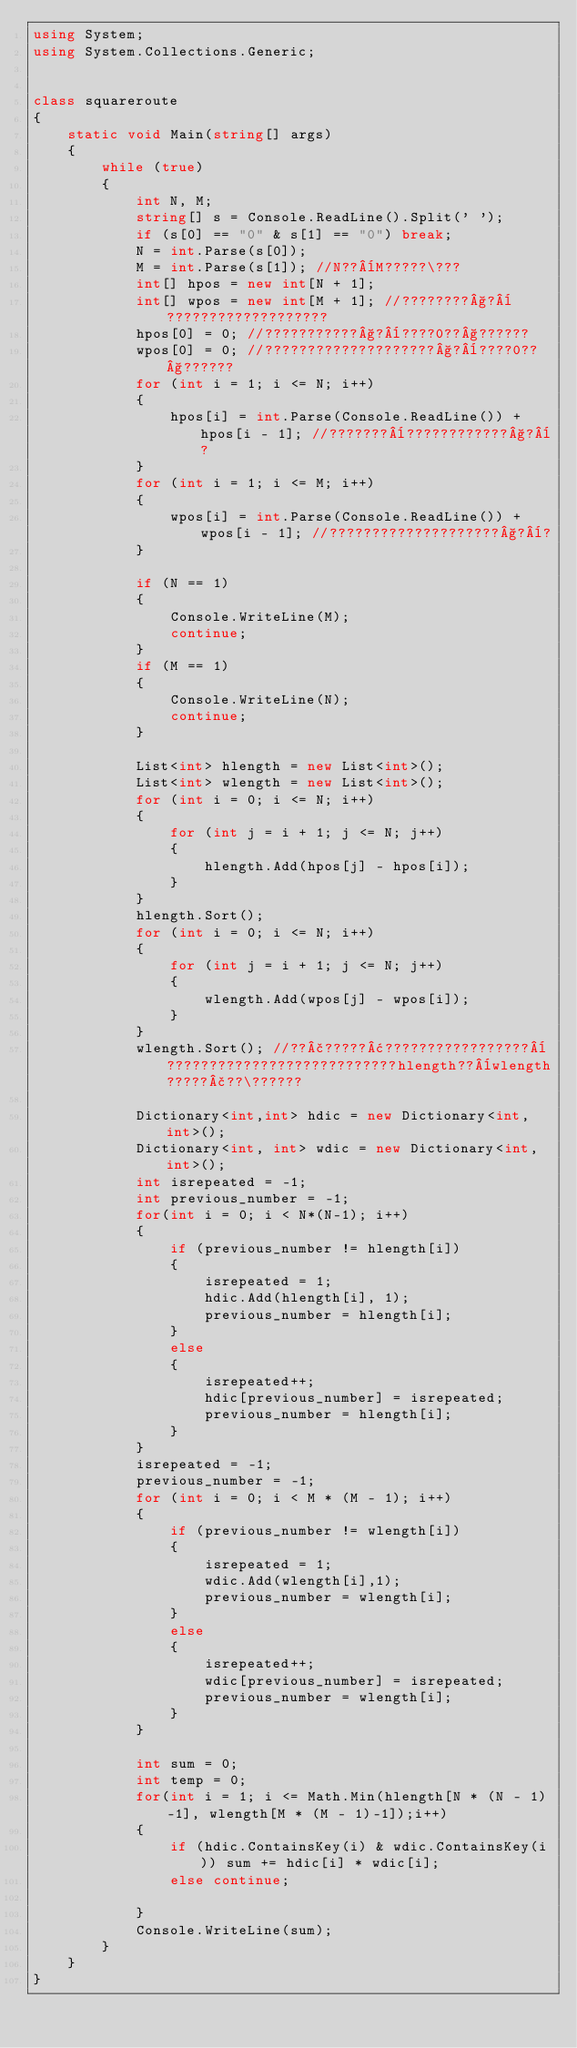<code> <loc_0><loc_0><loc_500><loc_500><_C#_>using System;
using System.Collections.Generic;


class squareroute
{
    static void Main(string[] args)
    {
        while (true)
        {
            int N, M;
            string[] s = Console.ReadLine().Split(' ');
            if (s[0] == "0" & s[1] == "0") break;
            N = int.Parse(s[0]);
            M = int.Parse(s[1]); //N??¨M?????\???
            int[] hpos = new int[N + 1];
            int[] wpos = new int[M + 1]; //????????§?¨???????????????????
            hpos[0] = 0; //???????????§?¨????0??§??????
            wpos[0] = 0; //????????????????????§?¨????0??§??????
            for (int i = 1; i <= N; i++)
            {
                hpos[i] = int.Parse(Console.ReadLine()) + hpos[i - 1]; //???????¨????????????§?¨?
            }
            for (int i = 1; i <= M; i++)
            {
                wpos[i] = int.Parse(Console.ReadLine()) + wpos[i - 1]; //????????????????????§?¨?
            }

            if (N == 1)
            {
                Console.WriteLine(M);
                continue;
            }
            if (M == 1)
            {
                Console.WriteLine(N);
                continue;
            }

            List<int> hlength = new List<int>();
            List<int> wlength = new List<int>();
            for (int i = 0; i <= N; i++)
            {
                for (int j = i + 1; j <= N; j++)
                {
                    hlength.Add(hpos[j] - hpos[i]);
                }
            }
            hlength.Sort();
            for (int i = 0; i <= N; i++)
            {
                for (int j = i + 1; j <= N; j++)
                {
                    wlength.Add(wpos[j] - wpos[i]);
                }
            }
            wlength.Sort(); //??£?????¢?????????????????¨???????????????????????????hlength??¨wlength?????£??\??????

            Dictionary<int,int> hdic = new Dictionary<int, int>();
            Dictionary<int, int> wdic = new Dictionary<int,int>();
            int isrepeated = -1;
            int previous_number = -1;
            for(int i = 0; i < N*(N-1); i++)
            {
                if (previous_number != hlength[i])
                {
                    isrepeated = 1;
                    hdic.Add(hlength[i], 1);
                    previous_number = hlength[i];
                }
                else
                {
                    isrepeated++;
                    hdic[previous_number] = isrepeated;
                    previous_number = hlength[i];
                }
            }
            isrepeated = -1;
            previous_number = -1;
            for (int i = 0; i < M * (M - 1); i++)
            {
                if (previous_number != wlength[i])
                {
                    isrepeated = 1;
                    wdic.Add(wlength[i],1);
                    previous_number = wlength[i];
                }
                else
                {
                    isrepeated++;
                    wdic[previous_number] = isrepeated;
                    previous_number = wlength[i];
                }
            }
            
            int sum = 0;
            int temp = 0;
            for(int i = 1; i <= Math.Min(hlength[N * (N - 1)-1], wlength[M * (M - 1)-1]);i++)
            {
                if (hdic.ContainsKey(i) & wdic.ContainsKey(i)) sum += hdic[i] * wdic[i];
                else continue;

            }
            Console.WriteLine(sum);
        }
    }
}</code> 